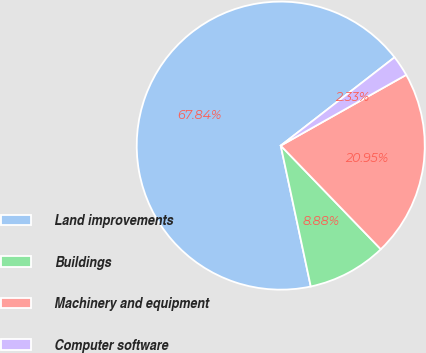<chart> <loc_0><loc_0><loc_500><loc_500><pie_chart><fcel>Land improvements<fcel>Buildings<fcel>Machinery and equipment<fcel>Computer software<nl><fcel>67.84%<fcel>8.88%<fcel>20.95%<fcel>2.33%<nl></chart> 